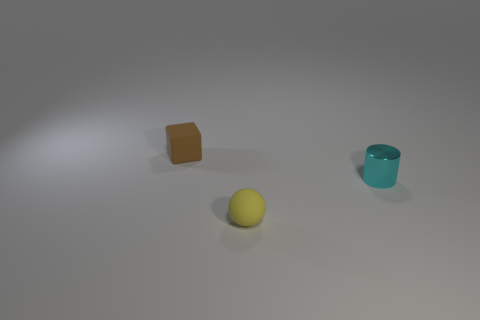Add 1 brown objects. How many objects exist? 4 Subtract all cylinders. How many objects are left? 2 Subtract 1 cyan cylinders. How many objects are left? 2 Subtract all small red shiny blocks. Subtract all small yellow rubber balls. How many objects are left? 2 Add 1 small rubber things. How many small rubber things are left? 3 Add 1 tiny things. How many tiny things exist? 4 